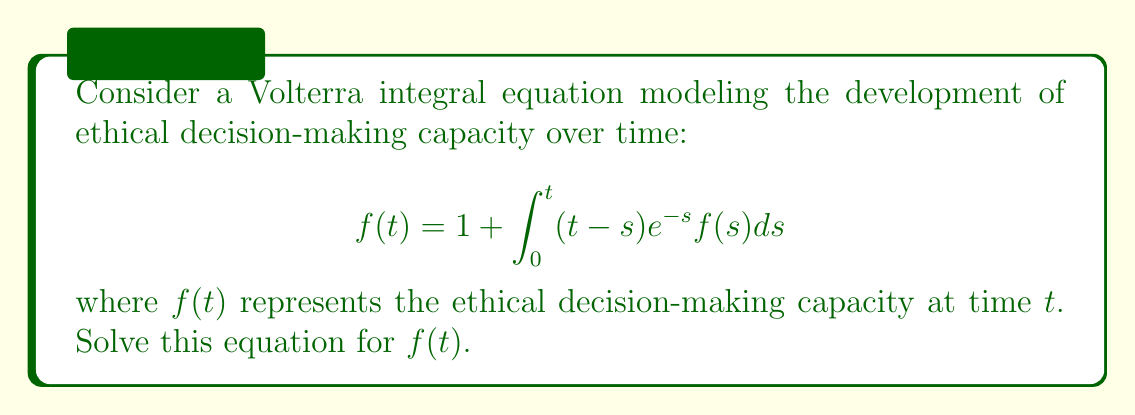Give your solution to this math problem. To solve this Volterra integral equation, we'll use the Laplace transform method:

1) Take the Laplace transform of both sides:
   $$\mathcal{L}\{f(t)\} = \mathcal{L}\{1\} + \mathcal{L}\{\int_0^t (t-s)e^{-s}f(s)ds\}$$

2) Let $F(p)$ be the Laplace transform of $f(t)$. Then:
   $$F(p) = \frac{1}{p} + \mathcal{L}\{(t-s)e^{-s}\} \cdot F(p)$$

3) The Laplace transform of $(t-s)e^{-s}$ is $\frac{1}{(p+1)^2}$, so:
   $$F(p) = \frac{1}{p} + \frac{1}{(p+1)^2}F(p)$$

4) Solve for $F(p)$:
   $$F(p) - \frac{1}{(p+1)^2}F(p) = \frac{1}{p}$$
   $$F(p)(\frac{(p+1)^2-1}{(p+1)^2}) = \frac{1}{p}$$
   $$F(p) = \frac{(p+1)^2}{p((p+1)^2-1)} = \frac{(p+1)^2}{p(p^2+2p)}$$

5) Decompose into partial fractions:
   $$F(p) = \frac{1}{p} + \frac{1}{p+2}$$

6) Take the inverse Laplace transform:
   $$f(t) = \mathcal{L}^{-1}\{\frac{1}{p} + \frac{1}{p+2}\} = 1 + e^{-2t}$$

Thus, we have solved for $f(t)$.
Answer: $f(t) = 1 + e^{-2t}$ 